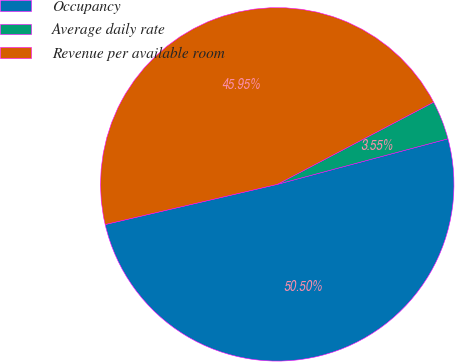Convert chart. <chart><loc_0><loc_0><loc_500><loc_500><pie_chart><fcel>Occupancy<fcel>Average daily rate<fcel>Revenue per available room<nl><fcel>50.51%<fcel>3.55%<fcel>45.95%<nl></chart> 